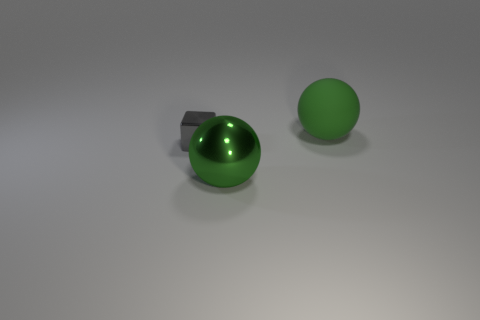Do the block and the sphere that is behind the tiny thing have the same material?
Give a very brief answer. No. The thing that is both behind the large metallic ball and right of the tiny metal object has what shape?
Make the answer very short. Sphere. What number of other objects are there of the same color as the tiny cube?
Offer a very short reply. 0. What is the shape of the tiny thing?
Ensure brevity in your answer.  Cube. There is a sphere in front of the shiny object behind the green metallic thing; what color is it?
Keep it short and to the point. Green. There is a big shiny object; is its color the same as the big ball that is behind the gray cube?
Provide a succinct answer. Yes. What is the thing that is both on the right side of the block and left of the rubber sphere made of?
Your answer should be compact. Metal. Is there a yellow matte block of the same size as the metal block?
Provide a short and direct response. No. There is a green object that is the same size as the rubber ball; what material is it?
Ensure brevity in your answer.  Metal. How many tiny gray metallic blocks are behind the gray metal block?
Your answer should be compact. 0. 